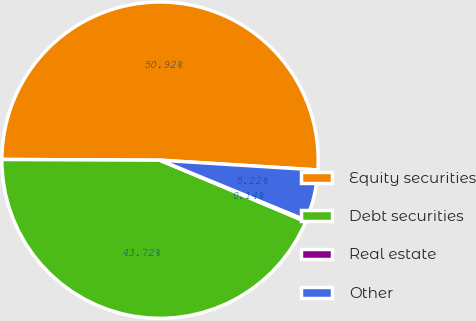<chart> <loc_0><loc_0><loc_500><loc_500><pie_chart><fcel>Equity securities<fcel>Debt securities<fcel>Real estate<fcel>Other<nl><fcel>50.92%<fcel>43.72%<fcel>0.14%<fcel>5.22%<nl></chart> 